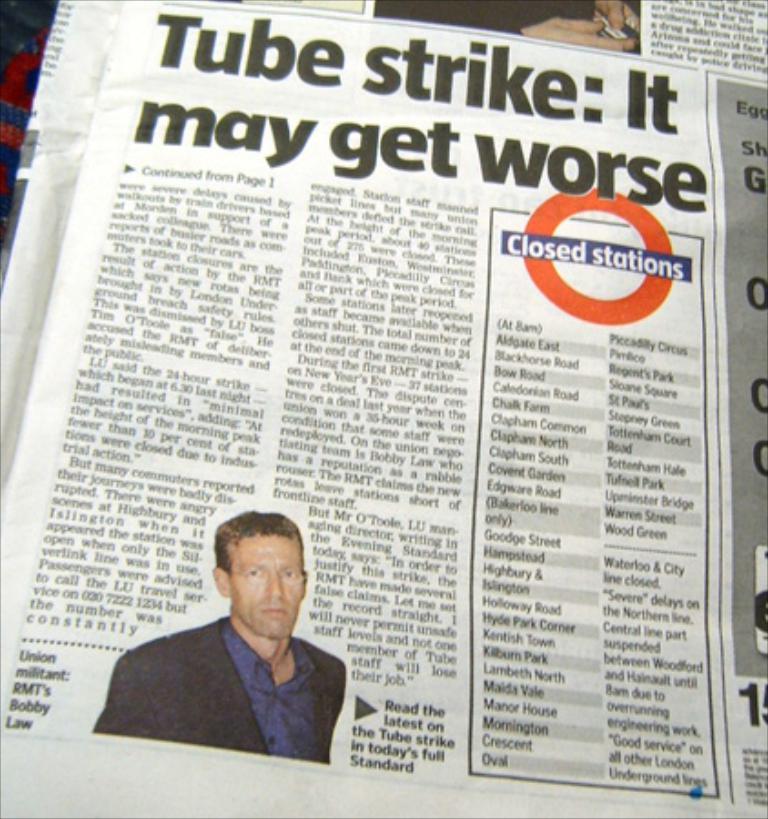What is the title of this article?
Offer a very short reply. Tube strike: it may get worse. According to this paper, what is closed?
Your answer should be very brief. Stations. 